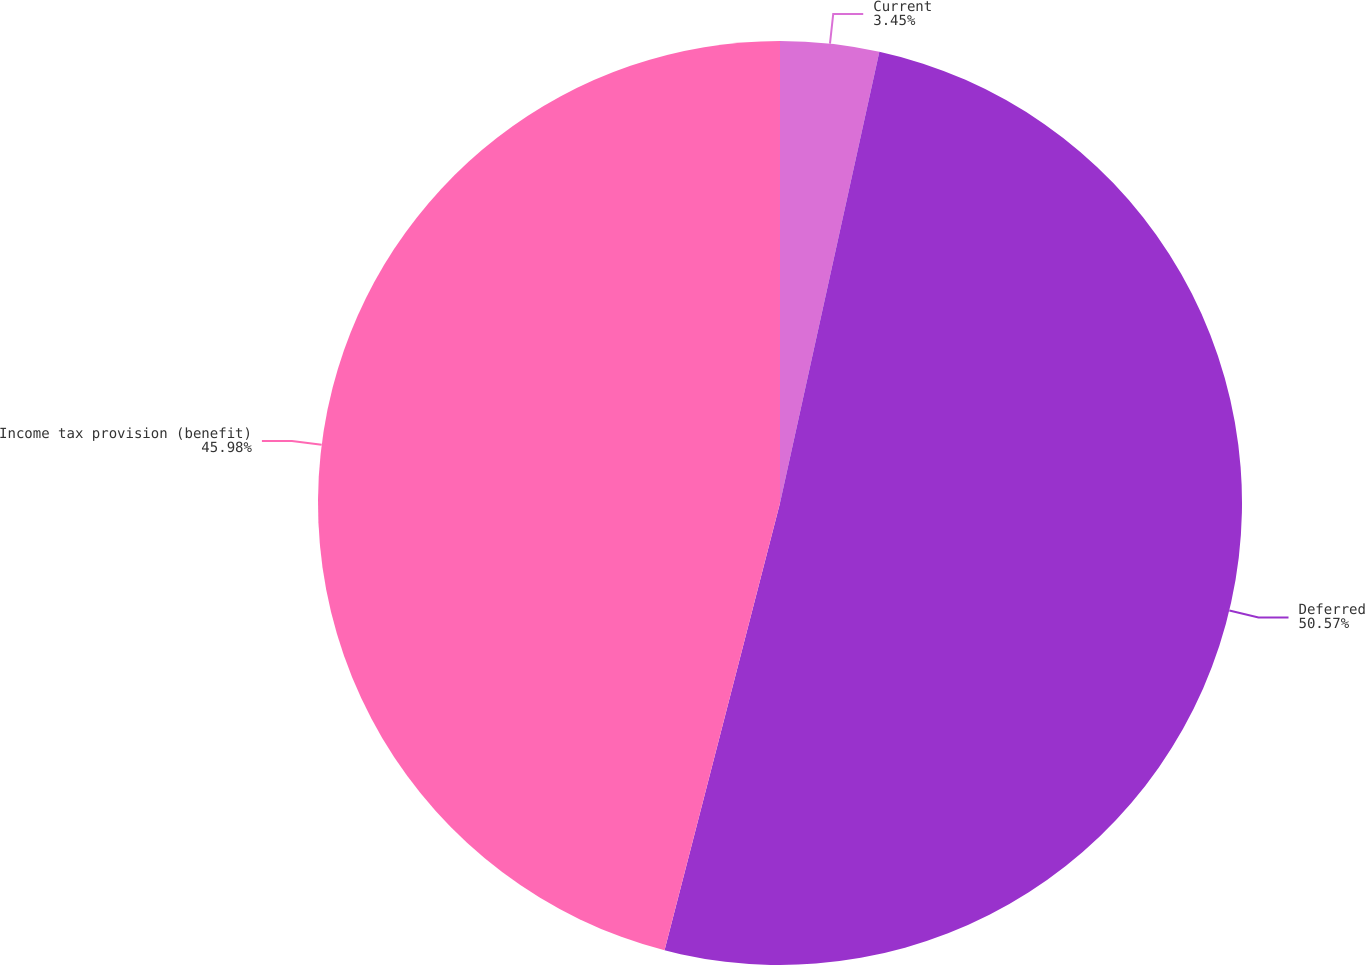Convert chart. <chart><loc_0><loc_0><loc_500><loc_500><pie_chart><fcel>Current<fcel>Deferred<fcel>Income tax provision (benefit)<nl><fcel>3.45%<fcel>50.57%<fcel>45.98%<nl></chart> 